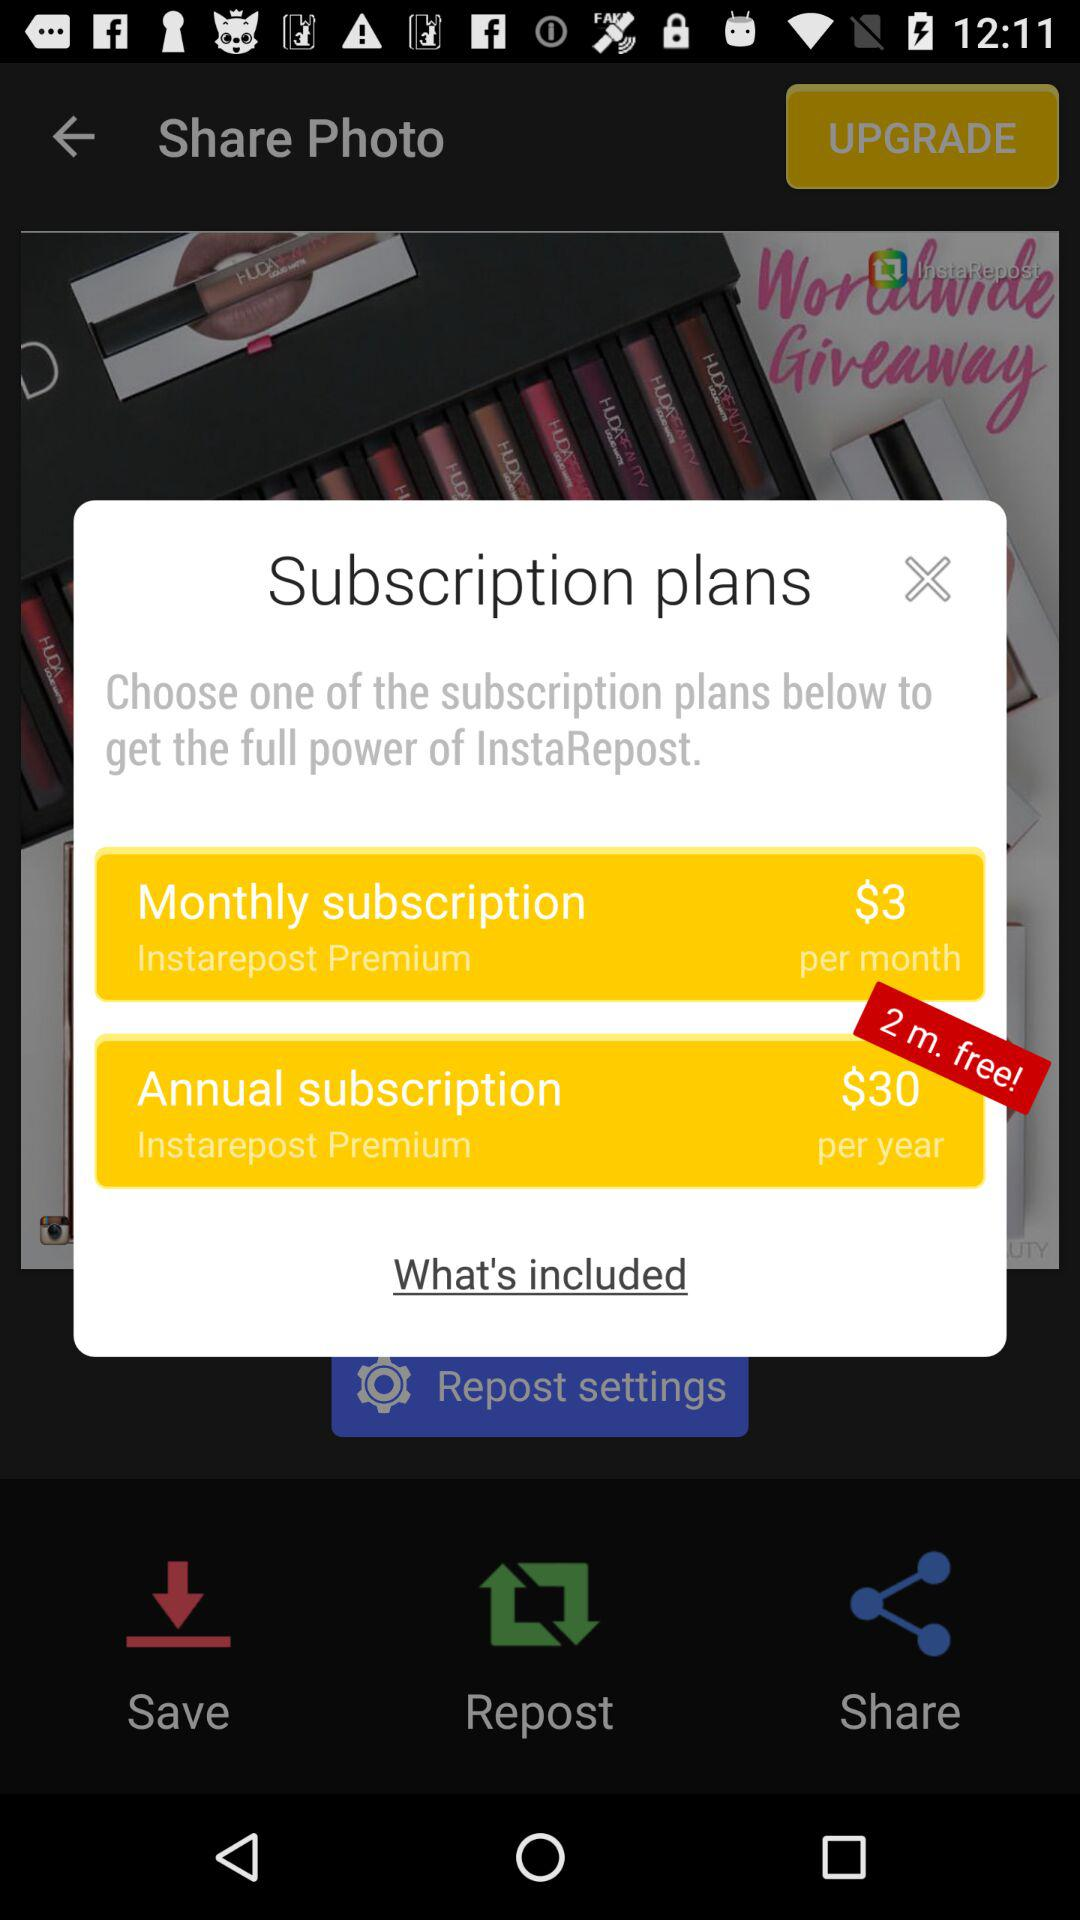How many months of free premium does the annual subscription include?
Answer the question using a single word or phrase. 2 